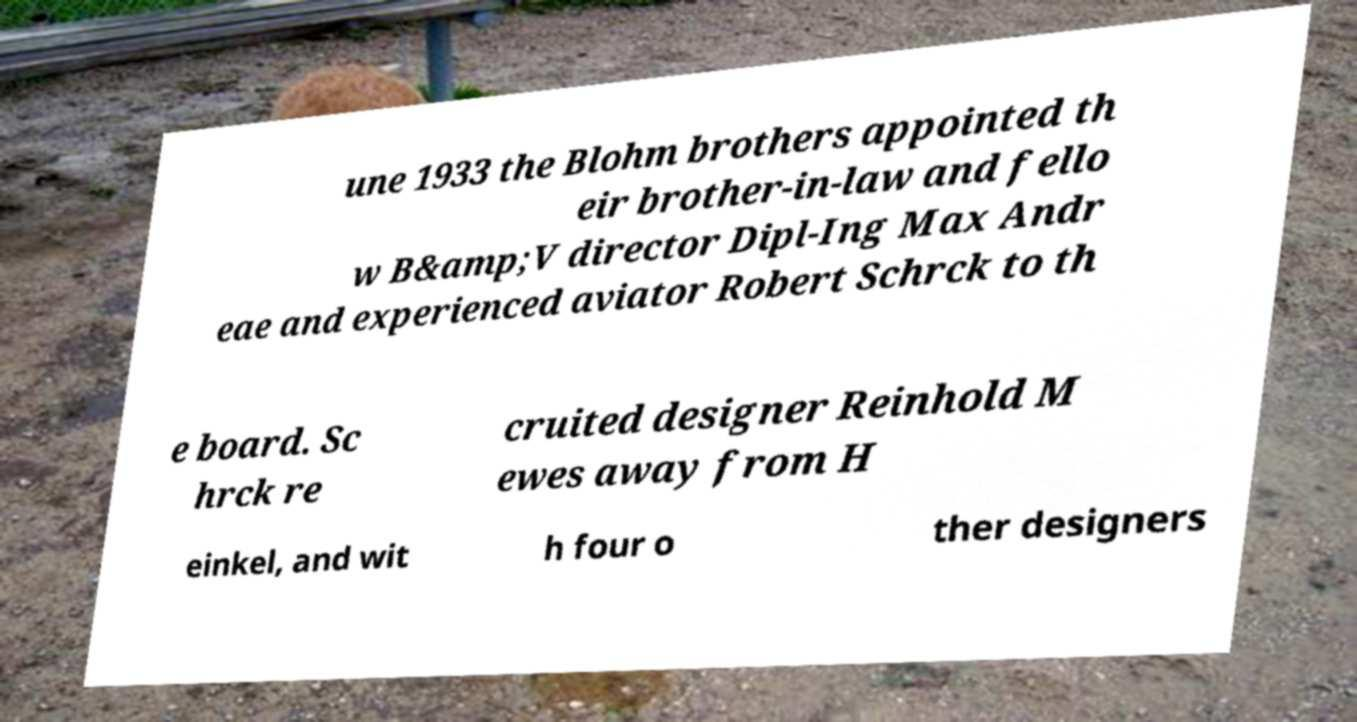There's text embedded in this image that I need extracted. Can you transcribe it verbatim? une 1933 the Blohm brothers appointed th eir brother-in-law and fello w B&amp;V director Dipl-Ing Max Andr eae and experienced aviator Robert Schrck to th e board. Sc hrck re cruited designer Reinhold M ewes away from H einkel, and wit h four o ther designers 